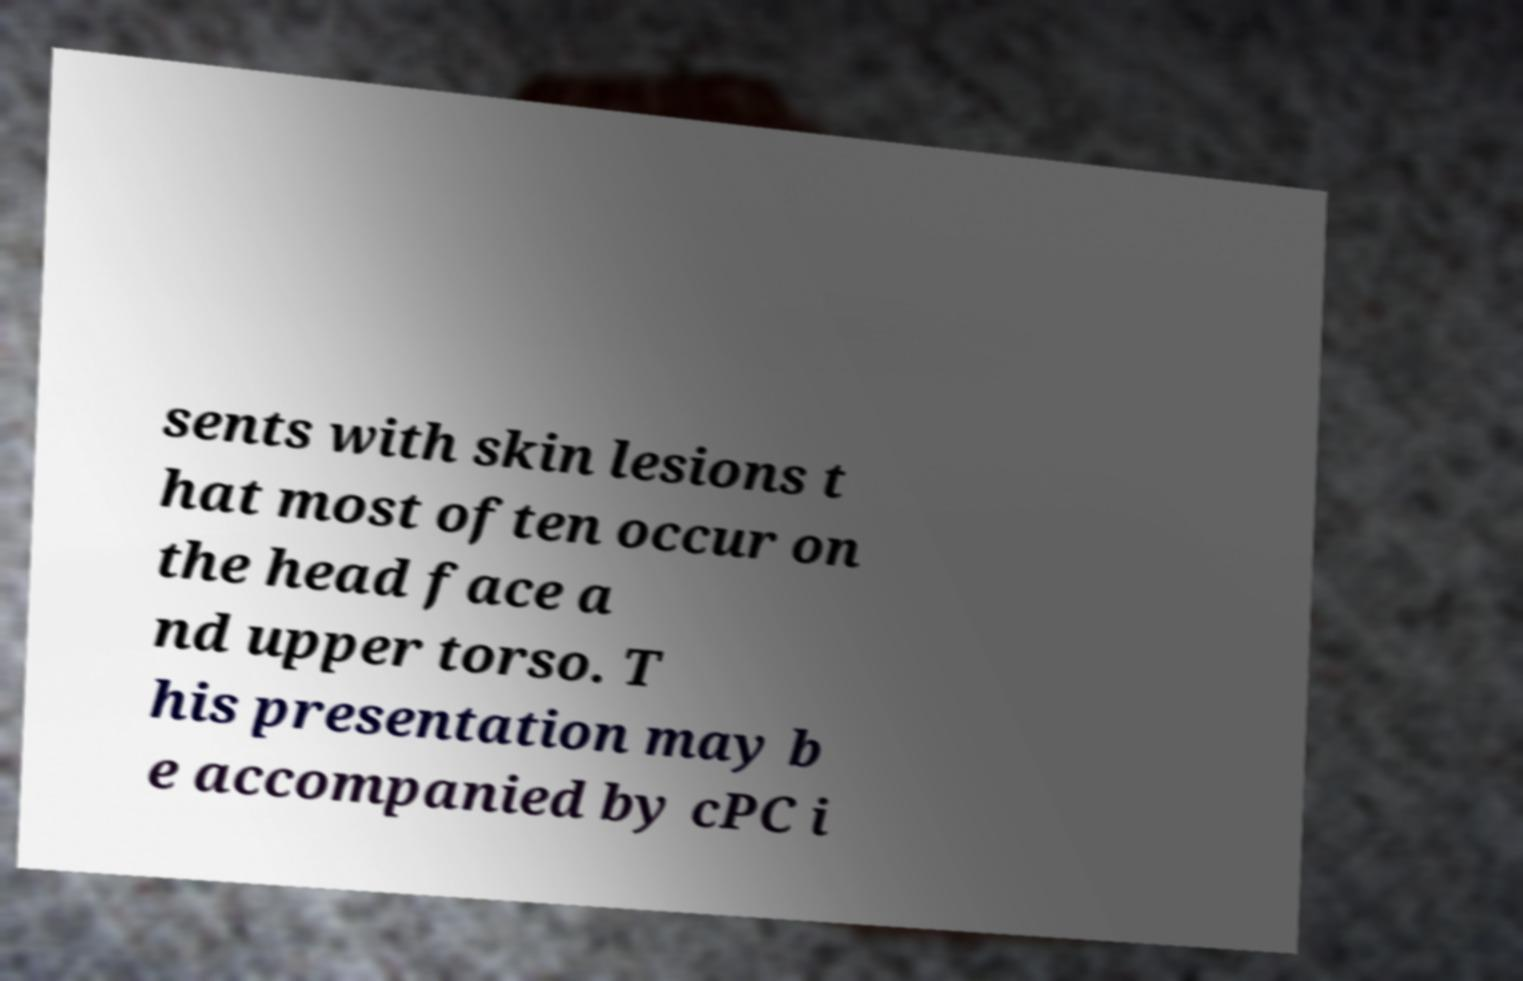There's text embedded in this image that I need extracted. Can you transcribe it verbatim? sents with skin lesions t hat most often occur on the head face a nd upper torso. T his presentation may b e accompanied by cPC i 